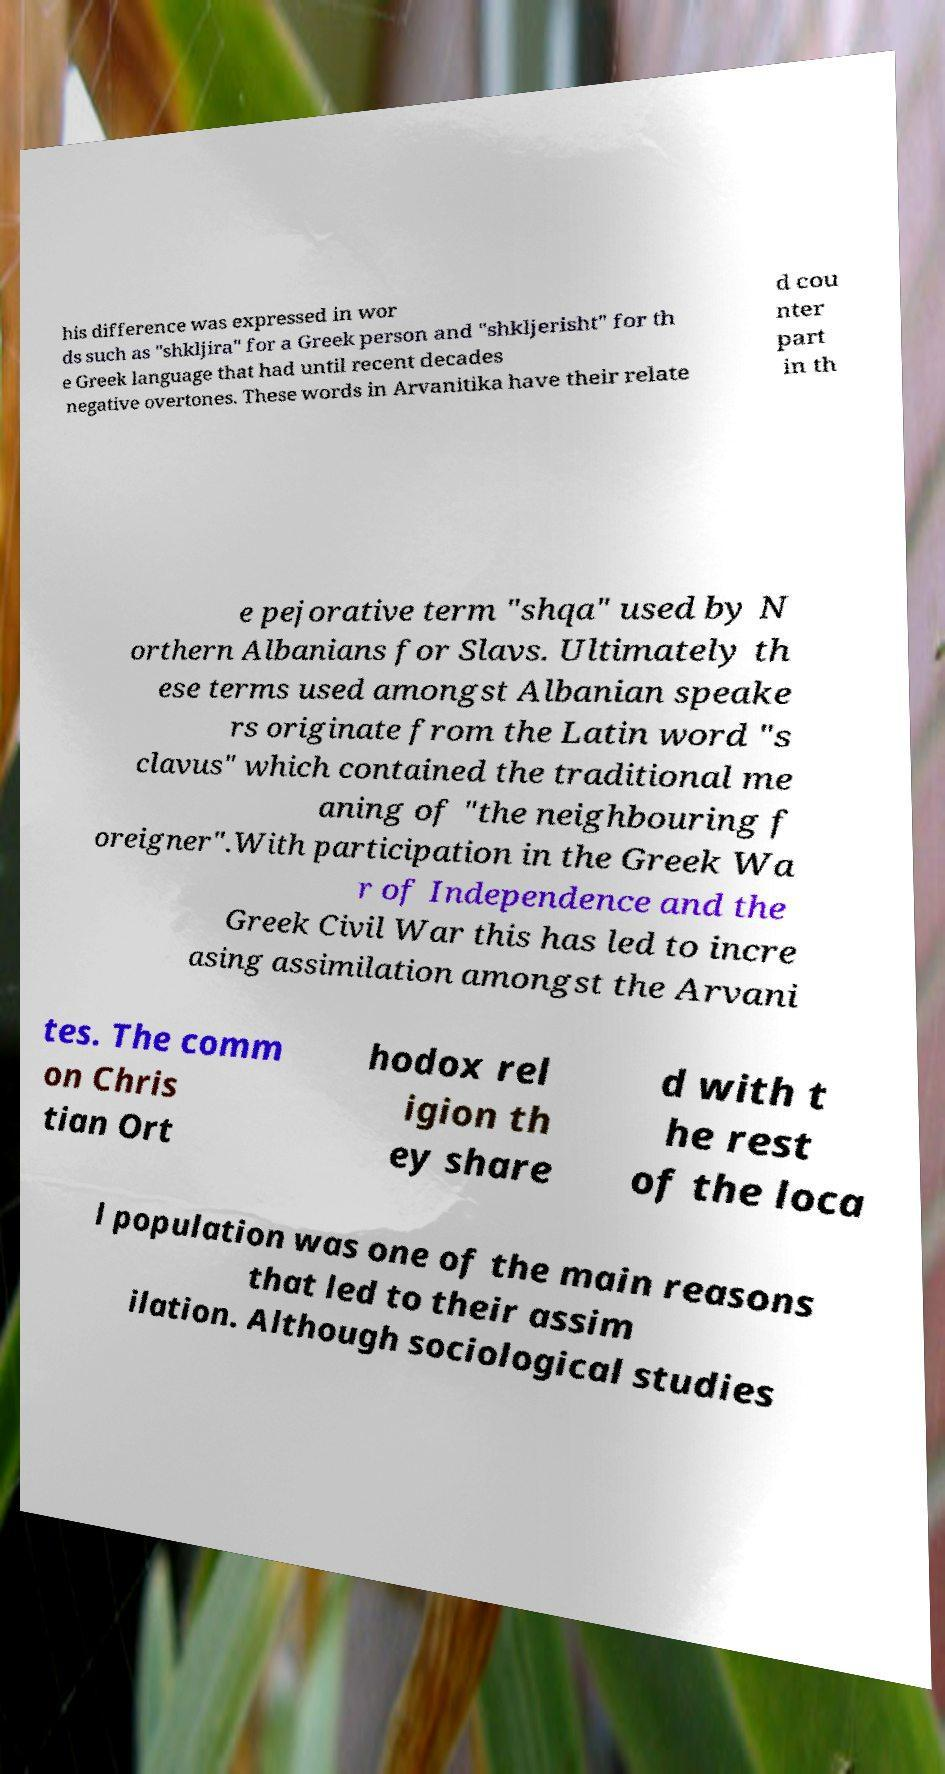Can you read and provide the text displayed in the image?This photo seems to have some interesting text. Can you extract and type it out for me? his difference was expressed in wor ds such as "shkljira" for a Greek person and "shkljerisht" for th e Greek language that had until recent decades negative overtones. These words in Arvanitika have their relate d cou nter part in th e pejorative term "shqa" used by N orthern Albanians for Slavs. Ultimately th ese terms used amongst Albanian speake rs originate from the Latin word "s clavus" which contained the traditional me aning of "the neighbouring f oreigner".With participation in the Greek Wa r of Independence and the Greek Civil War this has led to incre asing assimilation amongst the Arvani tes. The comm on Chris tian Ort hodox rel igion th ey share d with t he rest of the loca l population was one of the main reasons that led to their assim ilation. Although sociological studies 